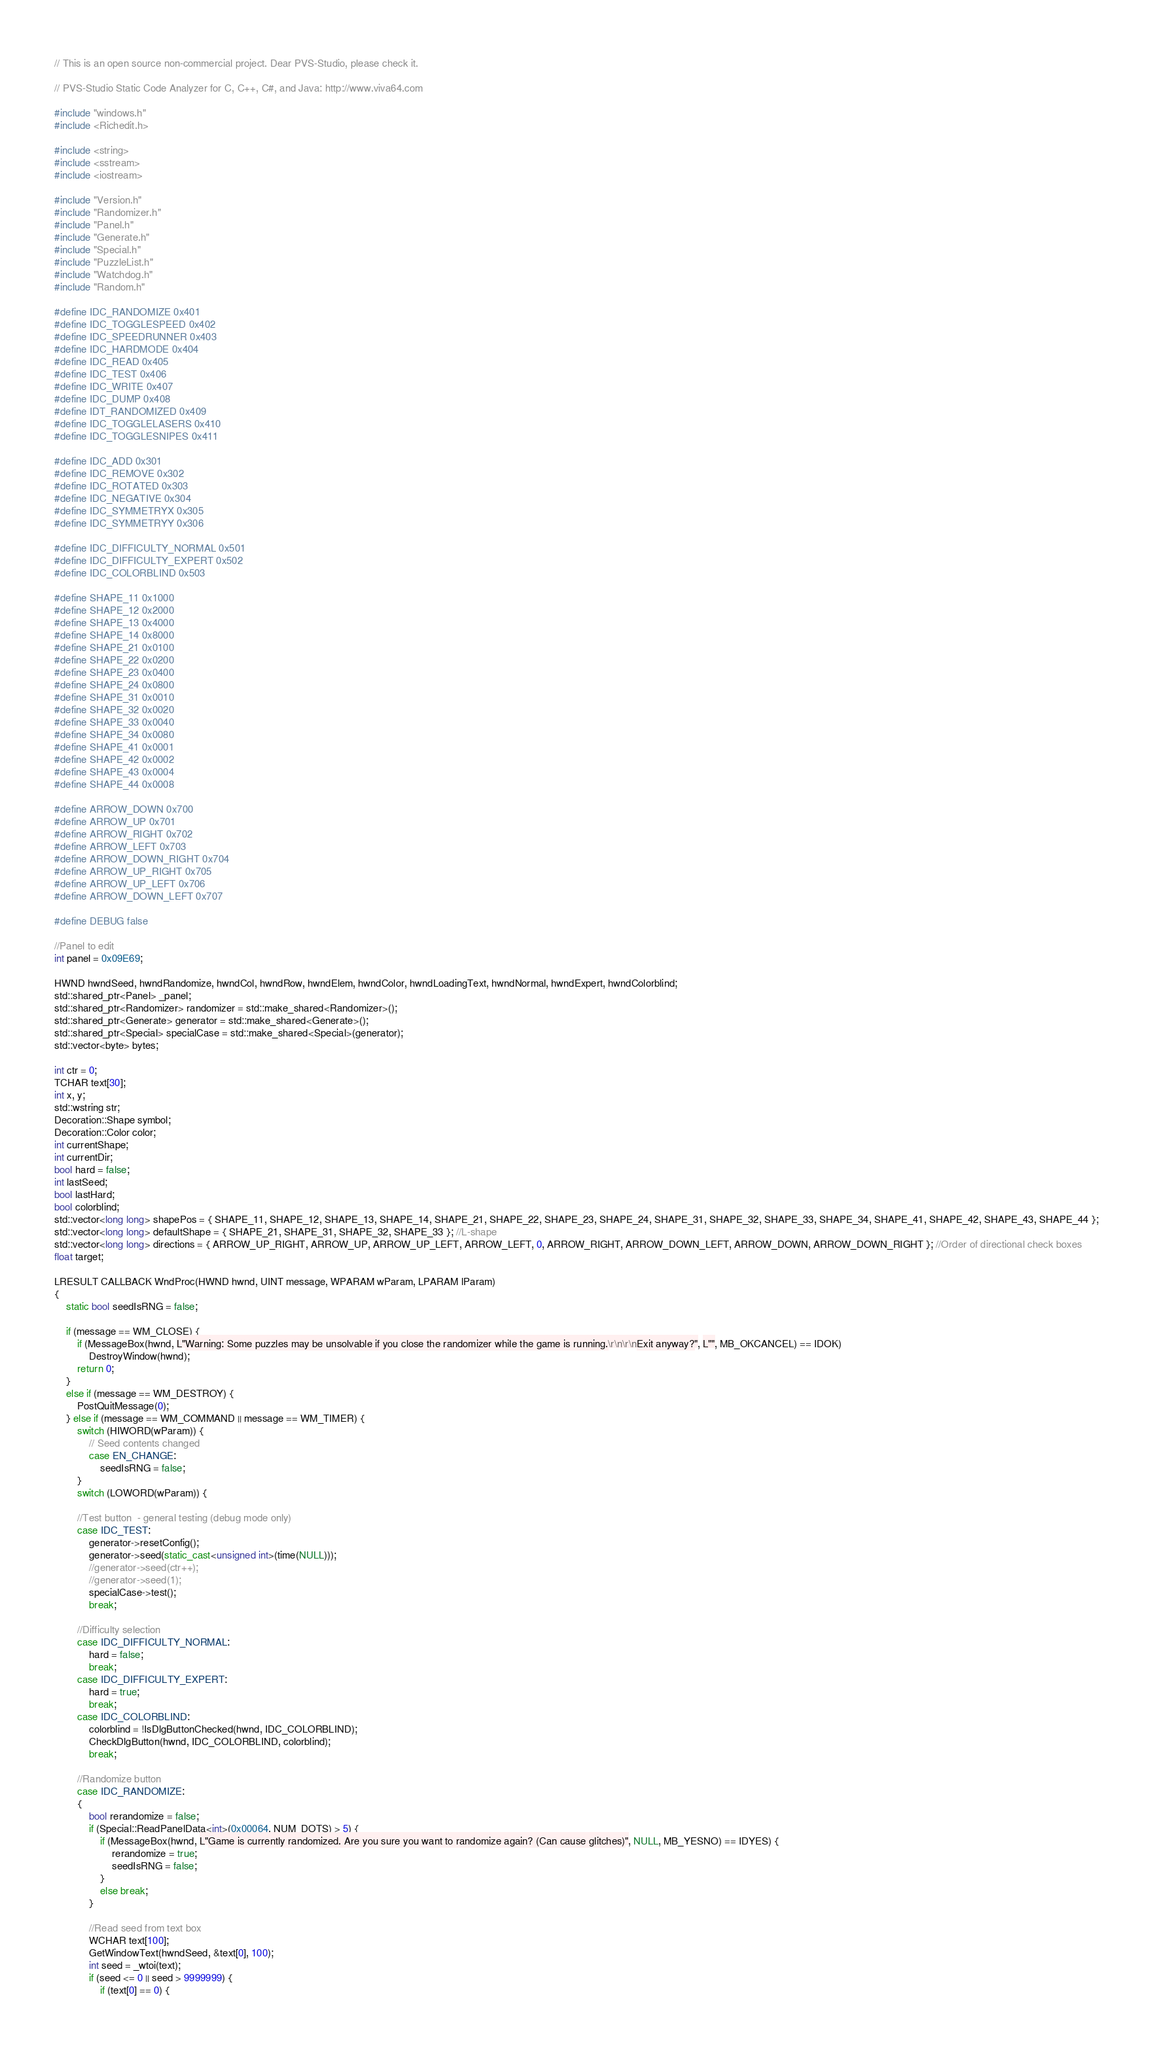Convert code to text. <code><loc_0><loc_0><loc_500><loc_500><_C++_>// This is an open source non-commercial project. Dear PVS-Studio, please check it.

// PVS-Studio Static Code Analyzer for C, C++, C#, and Java: http://www.viva64.com

#include "windows.h"
#include <Richedit.h>

#include <string>
#include <sstream>
#include <iostream>

#include "Version.h"
#include "Randomizer.h"
#include "Panel.h"
#include "Generate.h"
#include "Special.h"
#include "PuzzleList.h"
#include "Watchdog.h"
#include "Random.h"

#define IDC_RANDOMIZE 0x401
#define IDC_TOGGLESPEED 0x402
#define IDC_SPEEDRUNNER 0x403
#define IDC_HARDMODE 0x404
#define IDC_READ 0x405
#define IDC_TEST 0x406
#define IDC_WRITE 0x407
#define IDC_DUMP 0x408
#define IDT_RANDOMIZED 0x409
#define IDC_TOGGLELASERS 0x410
#define IDC_TOGGLESNIPES 0x411

#define IDC_ADD 0x301
#define IDC_REMOVE 0x302
#define IDC_ROTATED 0x303
#define IDC_NEGATIVE 0x304
#define IDC_SYMMETRYX 0x305
#define IDC_SYMMETRYY 0x306

#define IDC_DIFFICULTY_NORMAL 0x501
#define IDC_DIFFICULTY_EXPERT 0x502
#define IDC_COLORBLIND 0x503

#define SHAPE_11 0x1000
#define SHAPE_12 0x2000
#define SHAPE_13 0x4000
#define SHAPE_14 0x8000
#define SHAPE_21 0x0100
#define SHAPE_22 0x0200
#define SHAPE_23 0x0400
#define SHAPE_24 0x0800
#define SHAPE_31 0x0010
#define SHAPE_32 0x0020
#define SHAPE_33 0x0040
#define SHAPE_34 0x0080
#define SHAPE_41 0x0001
#define SHAPE_42 0x0002
#define SHAPE_43 0x0004
#define SHAPE_44 0x0008

#define ARROW_DOWN 0x700
#define ARROW_UP 0x701
#define ARROW_RIGHT 0x702
#define ARROW_LEFT 0x703
#define ARROW_DOWN_RIGHT 0x704
#define ARROW_UP_RIGHT 0x705
#define ARROW_UP_LEFT 0x706
#define ARROW_DOWN_LEFT 0x707

#define DEBUG false

//Panel to edit
int panel = 0x09E69;

HWND hwndSeed, hwndRandomize, hwndCol, hwndRow, hwndElem, hwndColor, hwndLoadingText, hwndNormal, hwndExpert, hwndColorblind;
std::shared_ptr<Panel> _panel;
std::shared_ptr<Randomizer> randomizer = std::make_shared<Randomizer>();
std::shared_ptr<Generate> generator = std::make_shared<Generate>();
std::shared_ptr<Special> specialCase = std::make_shared<Special>(generator);
std::vector<byte> bytes;

int ctr = 0;
TCHAR text[30];
int x, y;
std::wstring str;
Decoration::Shape symbol;
Decoration::Color color;
int currentShape;
int currentDir;
bool hard = false;
int lastSeed;
bool lastHard;
bool colorblind;
std::vector<long long> shapePos = { SHAPE_11, SHAPE_12, SHAPE_13, SHAPE_14, SHAPE_21, SHAPE_22, SHAPE_23, SHAPE_24, SHAPE_31, SHAPE_32, SHAPE_33, SHAPE_34, SHAPE_41, SHAPE_42, SHAPE_43, SHAPE_44 };
std::vector<long long> defaultShape = { SHAPE_21, SHAPE_31, SHAPE_32, SHAPE_33 }; //L-shape
std::vector<long long> directions = { ARROW_UP_RIGHT, ARROW_UP, ARROW_UP_LEFT, ARROW_LEFT, 0, ARROW_RIGHT, ARROW_DOWN_LEFT, ARROW_DOWN, ARROW_DOWN_RIGHT }; //Order of directional check boxes
float target;

LRESULT CALLBACK WndProc(HWND hwnd, UINT message, WPARAM wParam, LPARAM lParam)
{
	static bool seedIsRNG = false;

	if (message == WM_CLOSE) {
		if (MessageBox(hwnd, L"Warning: Some puzzles may be unsolvable if you close the randomizer while the game is running.\r\n\r\nExit anyway?", L"", MB_OKCANCEL) == IDOK)
			DestroyWindow(hwnd);
		return 0;
	}
	else if (message == WM_DESTROY) {
		PostQuitMessage(0);
	} else if (message == WM_COMMAND || message == WM_TIMER) {
		switch (HIWORD(wParam)) {
			// Seed contents changed
			case EN_CHANGE:
				seedIsRNG = false;
		}
		switch (LOWORD(wParam)) {

		//Test button  - general testing (debug mode only)
		case IDC_TEST:
			generator->resetConfig();
			generator->seed(static_cast<unsigned int>(time(NULL)));
			//generator->seed(ctr++);
			//generator->seed(1);
			specialCase->test();
			break;

		//Difficulty selection
		case IDC_DIFFICULTY_NORMAL:
			hard = false;
			break;
		case IDC_DIFFICULTY_EXPERT:
			hard = true;
			break;
		case IDC_COLORBLIND:
			colorblind = !IsDlgButtonChecked(hwnd, IDC_COLORBLIND);
			CheckDlgButton(hwnd, IDC_COLORBLIND, colorblind);
			break;

		//Randomize button
		case IDC_RANDOMIZE:
		{
			bool rerandomize = false;
			if (Special::ReadPanelData<int>(0x00064, NUM_DOTS) > 5) {
				if (MessageBox(hwnd, L"Game is currently randomized. Are you sure you want to randomize again? (Can cause glitches)", NULL, MB_YESNO) == IDYES) {
					rerandomize = true;
					seedIsRNG = false;
				}
				else break;
			}

			//Read seed from text box
			WCHAR text[100];
			GetWindowText(hwndSeed, &text[0], 100);
			int seed = _wtoi(text);
			if (seed <= 0 || seed > 9999999) {
				if (text[0] == 0) {</code> 